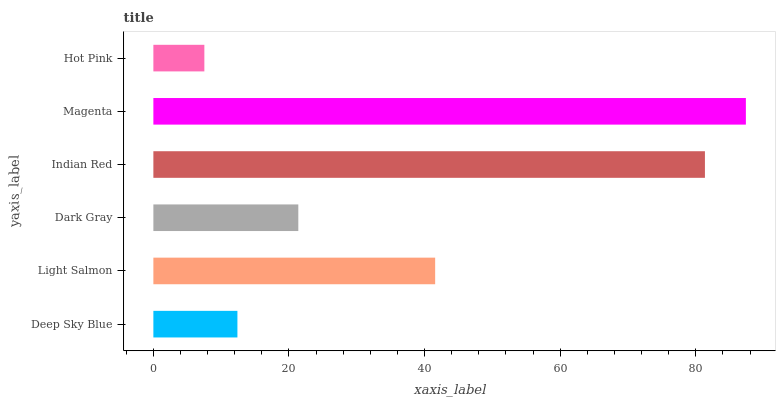Is Hot Pink the minimum?
Answer yes or no. Yes. Is Magenta the maximum?
Answer yes or no. Yes. Is Light Salmon the minimum?
Answer yes or no. No. Is Light Salmon the maximum?
Answer yes or no. No. Is Light Salmon greater than Deep Sky Blue?
Answer yes or no. Yes. Is Deep Sky Blue less than Light Salmon?
Answer yes or no. Yes. Is Deep Sky Blue greater than Light Salmon?
Answer yes or no. No. Is Light Salmon less than Deep Sky Blue?
Answer yes or no. No. Is Light Salmon the high median?
Answer yes or no. Yes. Is Dark Gray the low median?
Answer yes or no. Yes. Is Deep Sky Blue the high median?
Answer yes or no. No. Is Light Salmon the low median?
Answer yes or no. No. 